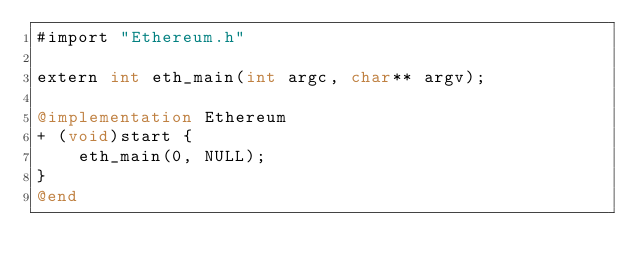Convert code to text. <code><loc_0><loc_0><loc_500><loc_500><_ObjectiveC_>#import "Ethereum.h"

extern int eth_main(int argc, char** argv);

@implementation Ethereum
+ (void)start {
    eth_main(0, NULL);
}
@end
</code> 